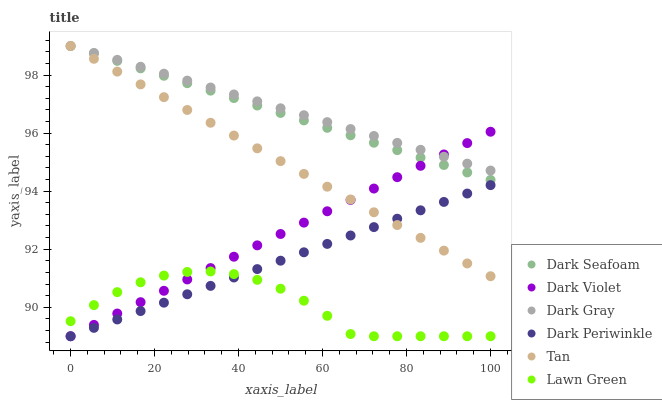Does Lawn Green have the minimum area under the curve?
Answer yes or no. Yes. Does Dark Gray have the maximum area under the curve?
Answer yes or no. Yes. Does Dark Violet have the minimum area under the curve?
Answer yes or no. No. Does Dark Violet have the maximum area under the curve?
Answer yes or no. No. Is Tan the smoothest?
Answer yes or no. Yes. Is Lawn Green the roughest?
Answer yes or no. Yes. Is Dark Violet the smoothest?
Answer yes or no. No. Is Dark Violet the roughest?
Answer yes or no. No. Does Lawn Green have the lowest value?
Answer yes or no. Yes. Does Dark Gray have the lowest value?
Answer yes or no. No. Does Tan have the highest value?
Answer yes or no. Yes. Does Dark Violet have the highest value?
Answer yes or no. No. Is Lawn Green less than Dark Seafoam?
Answer yes or no. Yes. Is Dark Gray greater than Lawn Green?
Answer yes or no. Yes. Does Dark Gray intersect Dark Seafoam?
Answer yes or no. Yes. Is Dark Gray less than Dark Seafoam?
Answer yes or no. No. Is Dark Gray greater than Dark Seafoam?
Answer yes or no. No. Does Lawn Green intersect Dark Seafoam?
Answer yes or no. No. 